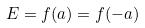<formula> <loc_0><loc_0><loc_500><loc_500>E = f ( a ) = f ( - a )</formula> 